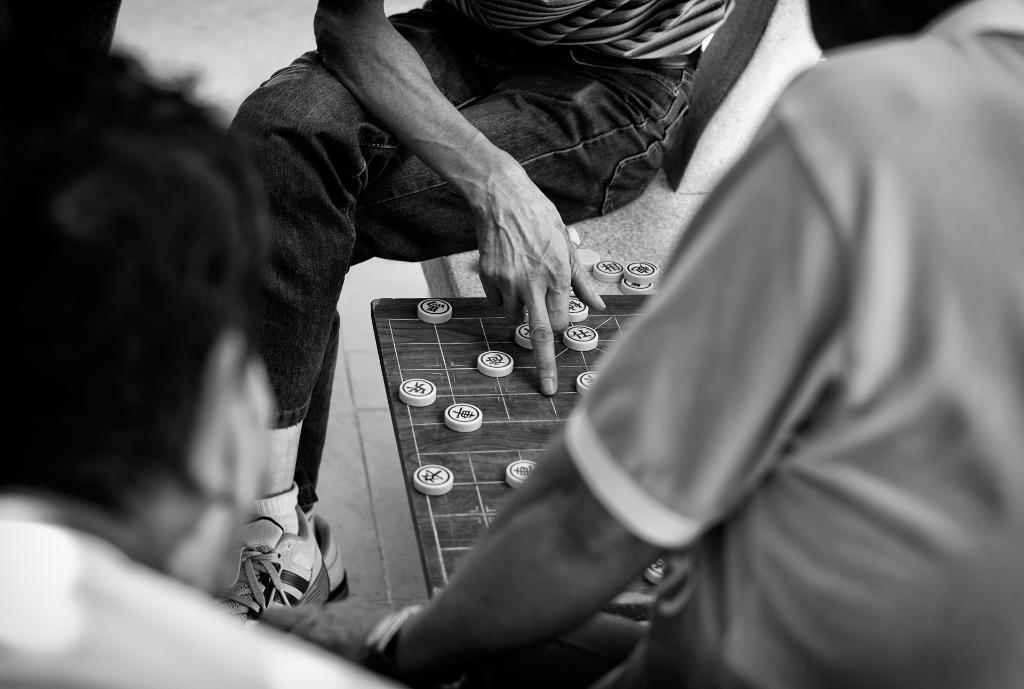What is the color scheme of the image? The image is black and white. Who or what can be seen in the image? There are people in the image. What object is present in the image? There is a board in the image. What else can be seen on the board? There are coins on the platform in the image. What type of vacation is being planned by the people in the image? There is no indication of a vacation in the image; it only shows people, a board, and coins on a platform. What knowledge can be gained from the image? The image itself does not convey any specific knowledge or information beyond the facts mentioned. 